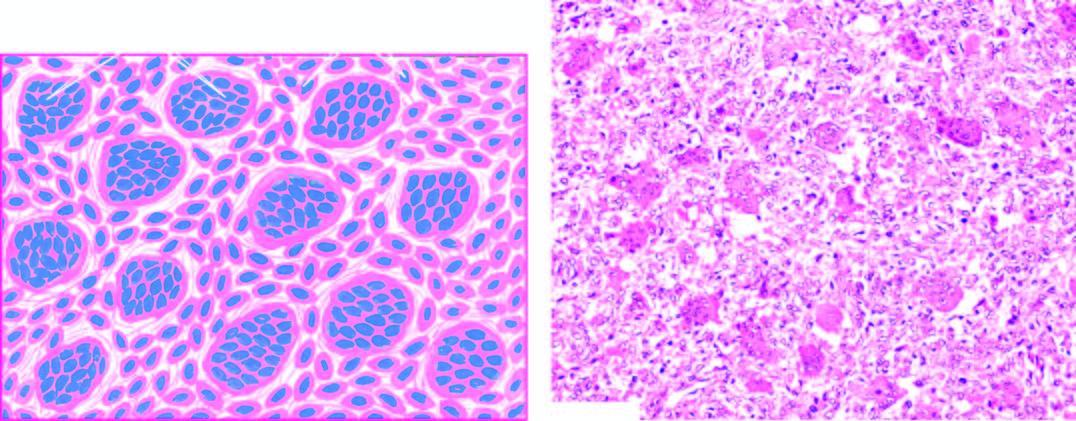what reveals osteoclast-like multinucleate giant cells which are regularly distributed among the mononuclear stromal cells?
Answer the question using a single word or phrase. Microscopy 